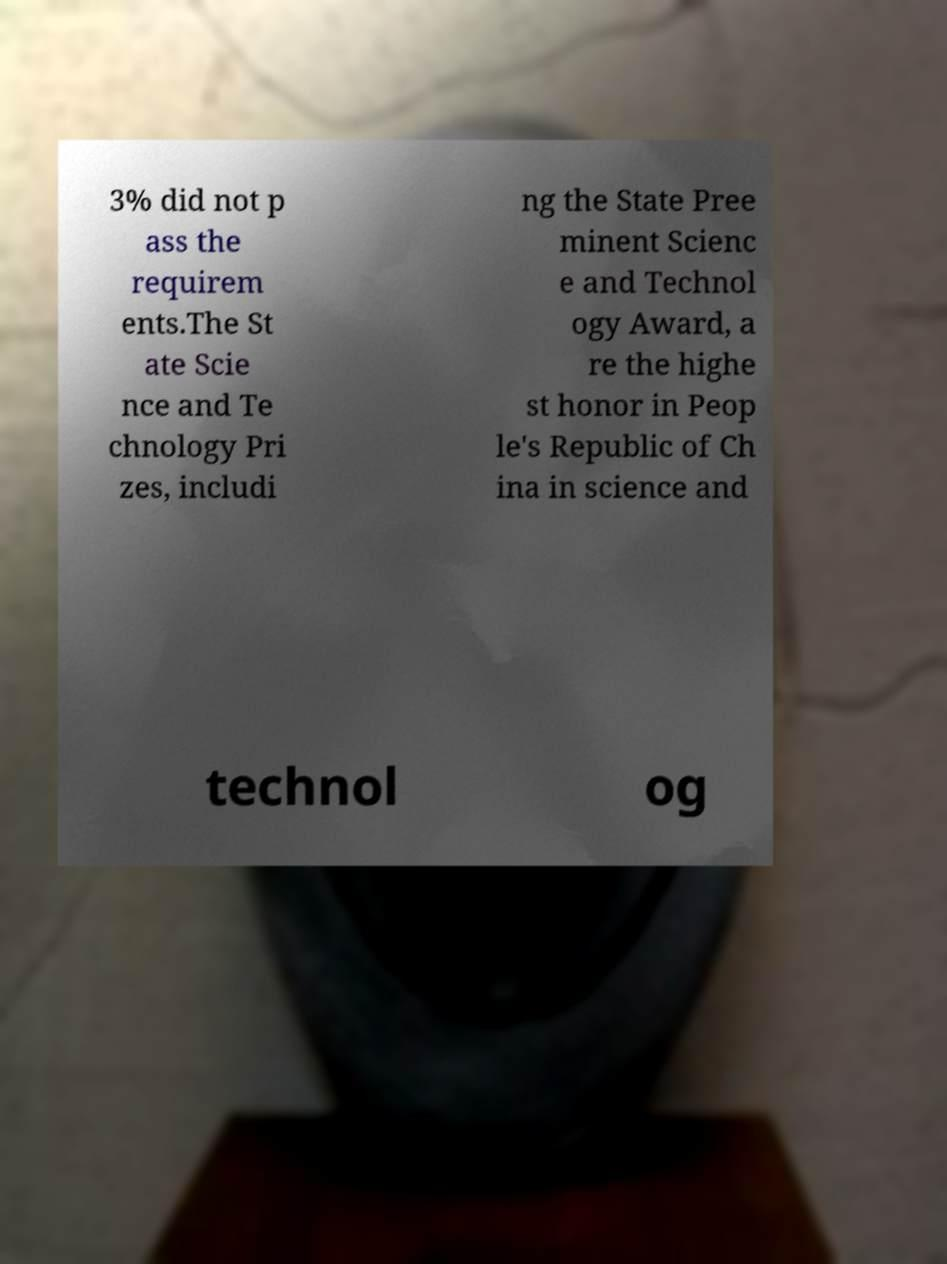For documentation purposes, I need the text within this image transcribed. Could you provide that? 3% did not p ass the requirem ents.The St ate Scie nce and Te chnology Pri zes, includi ng the State Pree minent Scienc e and Technol ogy Award, a re the highe st honor in Peop le's Republic of Ch ina in science and technol og 